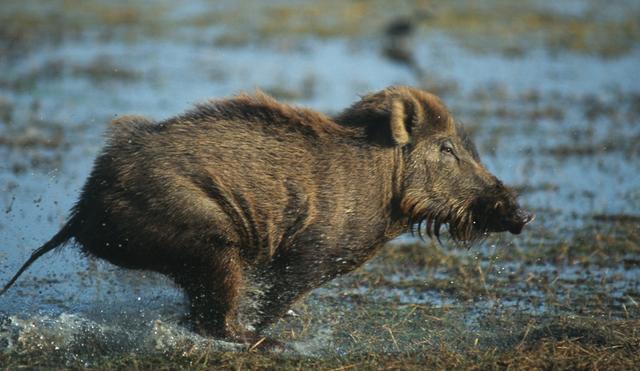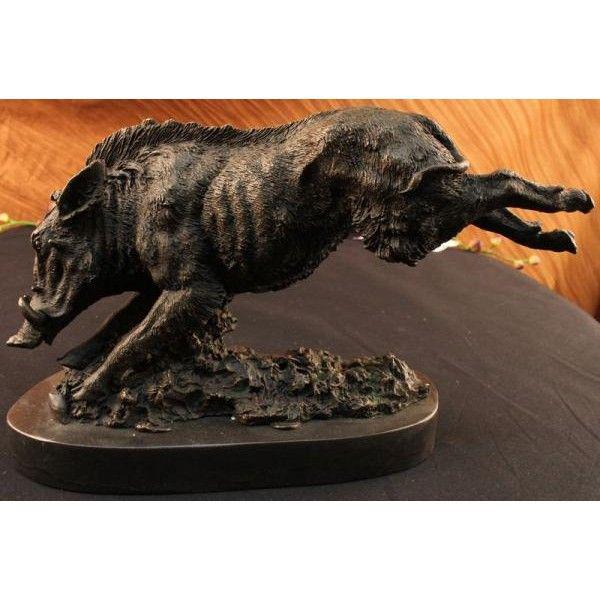The first image is the image on the left, the second image is the image on the right. For the images shown, is this caption "One image shows an actual wild pig bounding across the ground in profile, and each image includes an animal figure in a motion pose." true? Answer yes or no. Yes. The first image is the image on the left, the second image is the image on the right. Given the left and right images, does the statement "At least one wild boar is running toward the right, and another wild boar is running toward the left." hold true? Answer yes or no. Yes. 